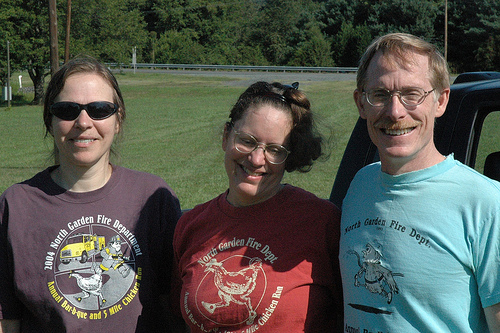<image>
Is there a tree next to the car? No. The tree is not positioned next to the car. They are located in different areas of the scene. Is there a tree behind the man? Yes. From this viewpoint, the tree is positioned behind the man, with the man partially or fully occluding the tree. 